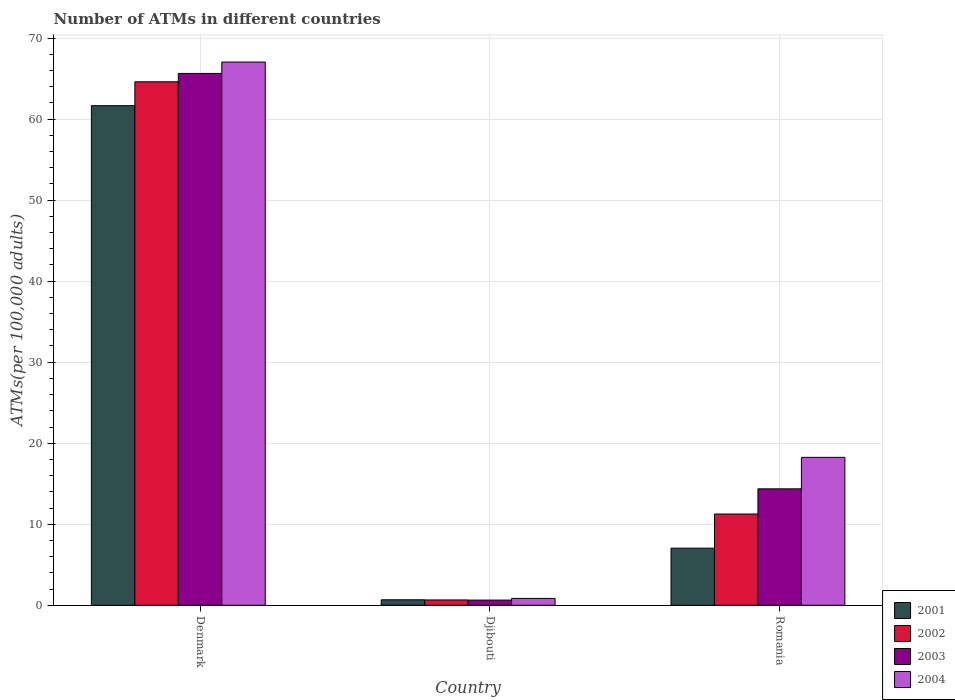How many different coloured bars are there?
Offer a terse response. 4. Are the number of bars per tick equal to the number of legend labels?
Offer a terse response. Yes. Are the number of bars on each tick of the X-axis equal?
Provide a short and direct response. Yes. How many bars are there on the 1st tick from the left?
Your response must be concise. 4. What is the label of the 3rd group of bars from the left?
Your answer should be compact. Romania. In how many cases, is the number of bars for a given country not equal to the number of legend labels?
Give a very brief answer. 0. What is the number of ATMs in 2002 in Denmark?
Ensure brevity in your answer.  64.61. Across all countries, what is the maximum number of ATMs in 2003?
Provide a succinct answer. 65.64. Across all countries, what is the minimum number of ATMs in 2004?
Offer a very short reply. 0.84. In which country was the number of ATMs in 2002 minimum?
Provide a short and direct response. Djibouti. What is the total number of ATMs in 2002 in the graph?
Make the answer very short. 76.52. What is the difference between the number of ATMs in 2002 in Denmark and that in Romania?
Provide a short and direct response. 53.35. What is the difference between the number of ATMs in 2004 in Djibouti and the number of ATMs in 2003 in Romania?
Give a very brief answer. -13.53. What is the average number of ATMs in 2002 per country?
Make the answer very short. 25.51. What is the difference between the number of ATMs of/in 2002 and number of ATMs of/in 2004 in Romania?
Make the answer very short. -7. In how many countries, is the number of ATMs in 2001 greater than 42?
Make the answer very short. 1. What is the ratio of the number of ATMs in 2002 in Denmark to that in Romania?
Provide a short and direct response. 5.74. Is the number of ATMs in 2003 in Djibouti less than that in Romania?
Make the answer very short. Yes. What is the difference between the highest and the second highest number of ATMs in 2004?
Give a very brief answer. -17.41. What is the difference between the highest and the lowest number of ATMs in 2003?
Ensure brevity in your answer.  65. Is it the case that in every country, the sum of the number of ATMs in 2001 and number of ATMs in 2004 is greater than the sum of number of ATMs in 2002 and number of ATMs in 2003?
Ensure brevity in your answer.  No. What does the 1st bar from the left in Denmark represents?
Your answer should be very brief. 2001. What does the 4th bar from the right in Romania represents?
Keep it short and to the point. 2001. How many bars are there?
Offer a terse response. 12. How many countries are there in the graph?
Offer a very short reply. 3. What is the difference between two consecutive major ticks on the Y-axis?
Provide a short and direct response. 10. Are the values on the major ticks of Y-axis written in scientific E-notation?
Ensure brevity in your answer.  No. Where does the legend appear in the graph?
Offer a very short reply. Bottom right. What is the title of the graph?
Keep it short and to the point. Number of ATMs in different countries. Does "2011" appear as one of the legend labels in the graph?
Your answer should be very brief. No. What is the label or title of the X-axis?
Your response must be concise. Country. What is the label or title of the Y-axis?
Ensure brevity in your answer.  ATMs(per 100,0 adults). What is the ATMs(per 100,000 adults) of 2001 in Denmark?
Your answer should be very brief. 61.66. What is the ATMs(per 100,000 adults) in 2002 in Denmark?
Your answer should be compact. 64.61. What is the ATMs(per 100,000 adults) of 2003 in Denmark?
Make the answer very short. 65.64. What is the ATMs(per 100,000 adults) in 2004 in Denmark?
Your response must be concise. 67.04. What is the ATMs(per 100,000 adults) of 2001 in Djibouti?
Offer a very short reply. 0.68. What is the ATMs(per 100,000 adults) in 2002 in Djibouti?
Give a very brief answer. 0.66. What is the ATMs(per 100,000 adults) of 2003 in Djibouti?
Offer a terse response. 0.64. What is the ATMs(per 100,000 adults) of 2004 in Djibouti?
Keep it short and to the point. 0.84. What is the ATMs(per 100,000 adults) of 2001 in Romania?
Your response must be concise. 7.04. What is the ATMs(per 100,000 adults) of 2002 in Romania?
Offer a terse response. 11.26. What is the ATMs(per 100,000 adults) of 2003 in Romania?
Provide a short and direct response. 14.37. What is the ATMs(per 100,000 adults) in 2004 in Romania?
Your response must be concise. 18.26. Across all countries, what is the maximum ATMs(per 100,000 adults) in 2001?
Provide a short and direct response. 61.66. Across all countries, what is the maximum ATMs(per 100,000 adults) in 2002?
Make the answer very short. 64.61. Across all countries, what is the maximum ATMs(per 100,000 adults) in 2003?
Keep it short and to the point. 65.64. Across all countries, what is the maximum ATMs(per 100,000 adults) in 2004?
Your response must be concise. 67.04. Across all countries, what is the minimum ATMs(per 100,000 adults) of 2001?
Keep it short and to the point. 0.68. Across all countries, what is the minimum ATMs(per 100,000 adults) of 2002?
Keep it short and to the point. 0.66. Across all countries, what is the minimum ATMs(per 100,000 adults) of 2003?
Your answer should be compact. 0.64. Across all countries, what is the minimum ATMs(per 100,000 adults) of 2004?
Your response must be concise. 0.84. What is the total ATMs(per 100,000 adults) in 2001 in the graph?
Offer a terse response. 69.38. What is the total ATMs(per 100,000 adults) of 2002 in the graph?
Your answer should be compact. 76.52. What is the total ATMs(per 100,000 adults) of 2003 in the graph?
Your answer should be compact. 80.65. What is the total ATMs(per 100,000 adults) of 2004 in the graph?
Your answer should be very brief. 86.14. What is the difference between the ATMs(per 100,000 adults) of 2001 in Denmark and that in Djibouti?
Keep it short and to the point. 60.98. What is the difference between the ATMs(per 100,000 adults) of 2002 in Denmark and that in Djibouti?
Your answer should be very brief. 63.95. What is the difference between the ATMs(per 100,000 adults) of 2003 in Denmark and that in Djibouti?
Offer a terse response. 65. What is the difference between the ATMs(per 100,000 adults) of 2004 in Denmark and that in Djibouti?
Your answer should be very brief. 66.2. What is the difference between the ATMs(per 100,000 adults) of 2001 in Denmark and that in Romania?
Provide a short and direct response. 54.61. What is the difference between the ATMs(per 100,000 adults) of 2002 in Denmark and that in Romania?
Give a very brief answer. 53.35. What is the difference between the ATMs(per 100,000 adults) in 2003 in Denmark and that in Romania?
Provide a succinct answer. 51.27. What is the difference between the ATMs(per 100,000 adults) of 2004 in Denmark and that in Romania?
Provide a succinct answer. 48.79. What is the difference between the ATMs(per 100,000 adults) of 2001 in Djibouti and that in Romania?
Provide a short and direct response. -6.37. What is the difference between the ATMs(per 100,000 adults) of 2002 in Djibouti and that in Romania?
Give a very brief answer. -10.6. What is the difference between the ATMs(per 100,000 adults) of 2003 in Djibouti and that in Romania?
Your answer should be very brief. -13.73. What is the difference between the ATMs(per 100,000 adults) in 2004 in Djibouti and that in Romania?
Provide a succinct answer. -17.41. What is the difference between the ATMs(per 100,000 adults) of 2001 in Denmark and the ATMs(per 100,000 adults) of 2002 in Djibouti?
Offer a very short reply. 61. What is the difference between the ATMs(per 100,000 adults) of 2001 in Denmark and the ATMs(per 100,000 adults) of 2003 in Djibouti?
Make the answer very short. 61.02. What is the difference between the ATMs(per 100,000 adults) of 2001 in Denmark and the ATMs(per 100,000 adults) of 2004 in Djibouti?
Your answer should be compact. 60.81. What is the difference between the ATMs(per 100,000 adults) in 2002 in Denmark and the ATMs(per 100,000 adults) in 2003 in Djibouti?
Offer a very short reply. 63.97. What is the difference between the ATMs(per 100,000 adults) of 2002 in Denmark and the ATMs(per 100,000 adults) of 2004 in Djibouti?
Offer a terse response. 63.76. What is the difference between the ATMs(per 100,000 adults) in 2003 in Denmark and the ATMs(per 100,000 adults) in 2004 in Djibouti?
Make the answer very short. 64.79. What is the difference between the ATMs(per 100,000 adults) in 2001 in Denmark and the ATMs(per 100,000 adults) in 2002 in Romania?
Make the answer very short. 50.4. What is the difference between the ATMs(per 100,000 adults) of 2001 in Denmark and the ATMs(per 100,000 adults) of 2003 in Romania?
Offer a terse response. 47.29. What is the difference between the ATMs(per 100,000 adults) of 2001 in Denmark and the ATMs(per 100,000 adults) of 2004 in Romania?
Offer a very short reply. 43.4. What is the difference between the ATMs(per 100,000 adults) of 2002 in Denmark and the ATMs(per 100,000 adults) of 2003 in Romania?
Your response must be concise. 50.24. What is the difference between the ATMs(per 100,000 adults) of 2002 in Denmark and the ATMs(per 100,000 adults) of 2004 in Romania?
Your answer should be very brief. 46.35. What is the difference between the ATMs(per 100,000 adults) in 2003 in Denmark and the ATMs(per 100,000 adults) in 2004 in Romania?
Make the answer very short. 47.38. What is the difference between the ATMs(per 100,000 adults) of 2001 in Djibouti and the ATMs(per 100,000 adults) of 2002 in Romania?
Give a very brief answer. -10.58. What is the difference between the ATMs(per 100,000 adults) in 2001 in Djibouti and the ATMs(per 100,000 adults) in 2003 in Romania?
Your response must be concise. -13.69. What is the difference between the ATMs(per 100,000 adults) in 2001 in Djibouti and the ATMs(per 100,000 adults) in 2004 in Romania?
Keep it short and to the point. -17.58. What is the difference between the ATMs(per 100,000 adults) of 2002 in Djibouti and the ATMs(per 100,000 adults) of 2003 in Romania?
Ensure brevity in your answer.  -13.71. What is the difference between the ATMs(per 100,000 adults) of 2002 in Djibouti and the ATMs(per 100,000 adults) of 2004 in Romania?
Your answer should be compact. -17.6. What is the difference between the ATMs(per 100,000 adults) in 2003 in Djibouti and the ATMs(per 100,000 adults) in 2004 in Romania?
Offer a terse response. -17.62. What is the average ATMs(per 100,000 adults) of 2001 per country?
Provide a short and direct response. 23.13. What is the average ATMs(per 100,000 adults) of 2002 per country?
Provide a succinct answer. 25.51. What is the average ATMs(per 100,000 adults) in 2003 per country?
Offer a terse response. 26.88. What is the average ATMs(per 100,000 adults) in 2004 per country?
Offer a very short reply. 28.71. What is the difference between the ATMs(per 100,000 adults) in 2001 and ATMs(per 100,000 adults) in 2002 in Denmark?
Provide a succinct answer. -2.95. What is the difference between the ATMs(per 100,000 adults) in 2001 and ATMs(per 100,000 adults) in 2003 in Denmark?
Offer a terse response. -3.98. What is the difference between the ATMs(per 100,000 adults) of 2001 and ATMs(per 100,000 adults) of 2004 in Denmark?
Your response must be concise. -5.39. What is the difference between the ATMs(per 100,000 adults) in 2002 and ATMs(per 100,000 adults) in 2003 in Denmark?
Ensure brevity in your answer.  -1.03. What is the difference between the ATMs(per 100,000 adults) in 2002 and ATMs(per 100,000 adults) in 2004 in Denmark?
Your response must be concise. -2.44. What is the difference between the ATMs(per 100,000 adults) in 2003 and ATMs(per 100,000 adults) in 2004 in Denmark?
Your answer should be compact. -1.41. What is the difference between the ATMs(per 100,000 adults) in 2001 and ATMs(per 100,000 adults) in 2002 in Djibouti?
Provide a short and direct response. 0.02. What is the difference between the ATMs(per 100,000 adults) in 2001 and ATMs(per 100,000 adults) in 2003 in Djibouti?
Keep it short and to the point. 0.04. What is the difference between the ATMs(per 100,000 adults) of 2001 and ATMs(per 100,000 adults) of 2004 in Djibouti?
Ensure brevity in your answer.  -0.17. What is the difference between the ATMs(per 100,000 adults) in 2002 and ATMs(per 100,000 adults) in 2003 in Djibouti?
Your answer should be very brief. 0.02. What is the difference between the ATMs(per 100,000 adults) in 2002 and ATMs(per 100,000 adults) in 2004 in Djibouti?
Offer a very short reply. -0.19. What is the difference between the ATMs(per 100,000 adults) in 2003 and ATMs(per 100,000 adults) in 2004 in Djibouti?
Make the answer very short. -0.21. What is the difference between the ATMs(per 100,000 adults) of 2001 and ATMs(per 100,000 adults) of 2002 in Romania?
Give a very brief answer. -4.21. What is the difference between the ATMs(per 100,000 adults) in 2001 and ATMs(per 100,000 adults) in 2003 in Romania?
Your response must be concise. -7.32. What is the difference between the ATMs(per 100,000 adults) of 2001 and ATMs(per 100,000 adults) of 2004 in Romania?
Ensure brevity in your answer.  -11.21. What is the difference between the ATMs(per 100,000 adults) in 2002 and ATMs(per 100,000 adults) in 2003 in Romania?
Your response must be concise. -3.11. What is the difference between the ATMs(per 100,000 adults) of 2002 and ATMs(per 100,000 adults) of 2004 in Romania?
Offer a very short reply. -7. What is the difference between the ATMs(per 100,000 adults) in 2003 and ATMs(per 100,000 adults) in 2004 in Romania?
Provide a succinct answer. -3.89. What is the ratio of the ATMs(per 100,000 adults) of 2001 in Denmark to that in Djibouti?
Offer a terse response. 91.18. What is the ratio of the ATMs(per 100,000 adults) of 2002 in Denmark to that in Djibouti?
Keep it short and to the point. 98.45. What is the ratio of the ATMs(per 100,000 adults) of 2003 in Denmark to that in Djibouti?
Your answer should be very brief. 102.88. What is the ratio of the ATMs(per 100,000 adults) in 2004 in Denmark to that in Djibouti?
Make the answer very short. 79.46. What is the ratio of the ATMs(per 100,000 adults) in 2001 in Denmark to that in Romania?
Your answer should be very brief. 8.75. What is the ratio of the ATMs(per 100,000 adults) in 2002 in Denmark to that in Romania?
Keep it short and to the point. 5.74. What is the ratio of the ATMs(per 100,000 adults) of 2003 in Denmark to that in Romania?
Offer a very short reply. 4.57. What is the ratio of the ATMs(per 100,000 adults) in 2004 in Denmark to that in Romania?
Ensure brevity in your answer.  3.67. What is the ratio of the ATMs(per 100,000 adults) in 2001 in Djibouti to that in Romania?
Keep it short and to the point. 0.1. What is the ratio of the ATMs(per 100,000 adults) of 2002 in Djibouti to that in Romania?
Your answer should be compact. 0.06. What is the ratio of the ATMs(per 100,000 adults) of 2003 in Djibouti to that in Romania?
Offer a very short reply. 0.04. What is the ratio of the ATMs(per 100,000 adults) in 2004 in Djibouti to that in Romania?
Make the answer very short. 0.05. What is the difference between the highest and the second highest ATMs(per 100,000 adults) of 2001?
Ensure brevity in your answer.  54.61. What is the difference between the highest and the second highest ATMs(per 100,000 adults) of 2002?
Make the answer very short. 53.35. What is the difference between the highest and the second highest ATMs(per 100,000 adults) in 2003?
Make the answer very short. 51.27. What is the difference between the highest and the second highest ATMs(per 100,000 adults) of 2004?
Provide a short and direct response. 48.79. What is the difference between the highest and the lowest ATMs(per 100,000 adults) in 2001?
Ensure brevity in your answer.  60.98. What is the difference between the highest and the lowest ATMs(per 100,000 adults) of 2002?
Make the answer very short. 63.95. What is the difference between the highest and the lowest ATMs(per 100,000 adults) of 2003?
Your answer should be compact. 65. What is the difference between the highest and the lowest ATMs(per 100,000 adults) of 2004?
Offer a very short reply. 66.2. 